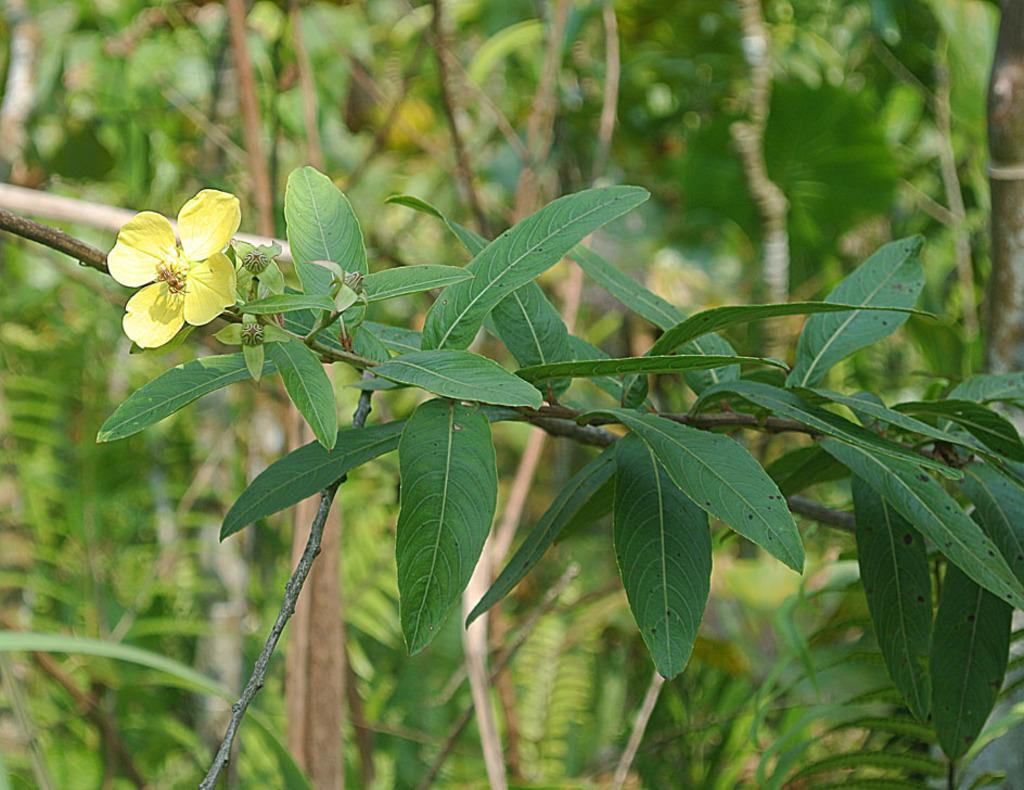What is the main subject of the image? There is a flower in the image. What color is the flower? The flower is yellow in color. Are there any other parts of the plant visible in the image? Yes, there are leaves associated with the flower. How would you describe the background of the image? The background of the image is blurred. What development is taking place in the image? There is no development taking place in the image; it is a static image of a yellow flower with leaves and a blurred background. 